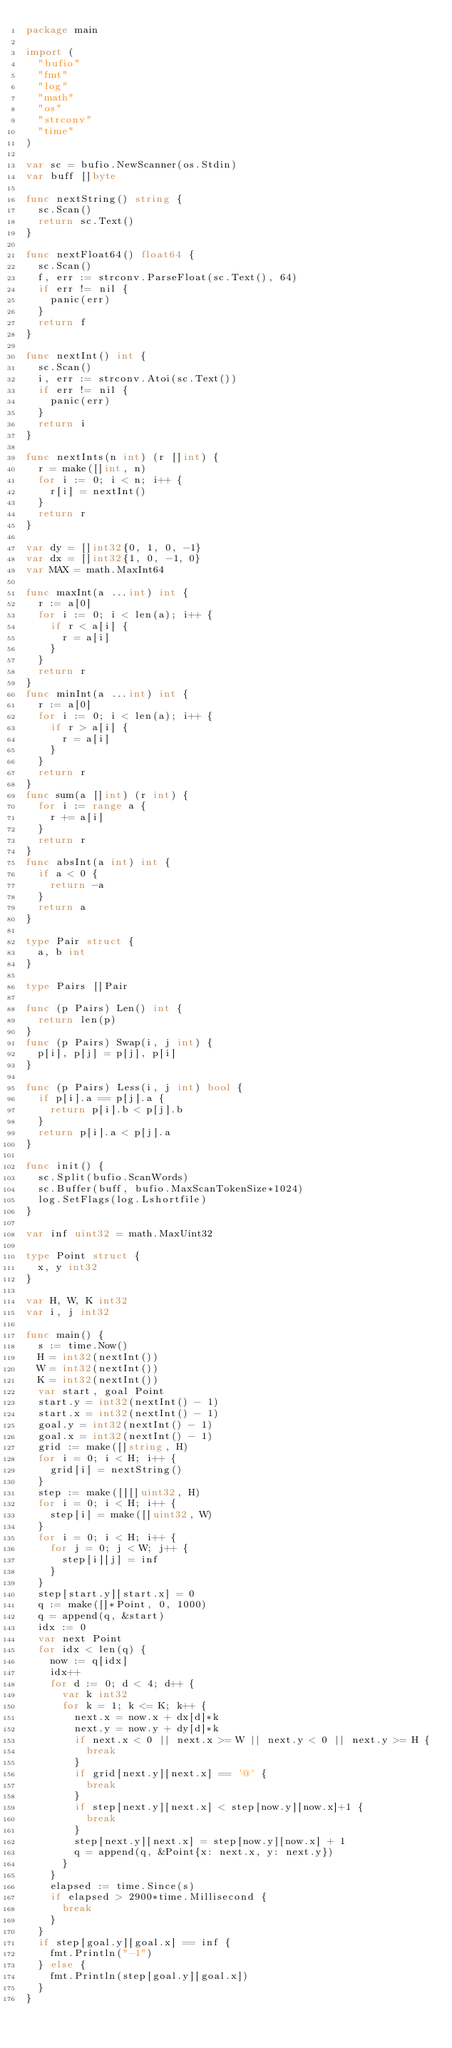<code> <loc_0><loc_0><loc_500><loc_500><_Go_>package main

import (
	"bufio"
	"fmt"
	"log"
	"math"
	"os"
	"strconv"
	"time"
)

var sc = bufio.NewScanner(os.Stdin)
var buff []byte

func nextString() string {
	sc.Scan()
	return sc.Text()
}

func nextFloat64() float64 {
	sc.Scan()
	f, err := strconv.ParseFloat(sc.Text(), 64)
	if err != nil {
		panic(err)
	}
	return f
}

func nextInt() int {
	sc.Scan()
	i, err := strconv.Atoi(sc.Text())
	if err != nil {
		panic(err)
	}
	return i
}

func nextInts(n int) (r []int) {
	r = make([]int, n)
	for i := 0; i < n; i++ {
		r[i] = nextInt()
	}
	return r
}

var dy = []int32{0, 1, 0, -1}
var dx = []int32{1, 0, -1, 0}
var MAX = math.MaxInt64

func maxInt(a ...int) int {
	r := a[0]
	for i := 0; i < len(a); i++ {
		if r < a[i] {
			r = a[i]
		}
	}
	return r
}
func minInt(a ...int) int {
	r := a[0]
	for i := 0; i < len(a); i++ {
		if r > a[i] {
			r = a[i]
		}
	}
	return r
}
func sum(a []int) (r int) {
	for i := range a {
		r += a[i]
	}
	return r
}
func absInt(a int) int {
	if a < 0 {
		return -a
	}
	return a
}

type Pair struct {
	a, b int
}

type Pairs []Pair

func (p Pairs) Len() int {
	return len(p)
}
func (p Pairs) Swap(i, j int) {
	p[i], p[j] = p[j], p[i]
}

func (p Pairs) Less(i, j int) bool {
	if p[i].a == p[j].a {
		return p[i].b < p[j].b
	}
	return p[i].a < p[j].a
}

func init() {
	sc.Split(bufio.ScanWords)
	sc.Buffer(buff, bufio.MaxScanTokenSize*1024)
	log.SetFlags(log.Lshortfile)
}

var inf uint32 = math.MaxUint32

type Point struct {
	x, y int32
}

var H, W, K int32
var i, j int32

func main() {
	s := time.Now()
	H = int32(nextInt())
	W = int32(nextInt())
	K = int32(nextInt())
	var start, goal Point
	start.y = int32(nextInt() - 1)
	start.x = int32(nextInt() - 1)
	goal.y = int32(nextInt() - 1)
	goal.x = int32(nextInt() - 1)
	grid := make([]string, H)
	for i = 0; i < H; i++ {
		grid[i] = nextString()
	}
	step := make([][]uint32, H)
	for i = 0; i < H; i++ {
		step[i] = make([]uint32, W)
	}
	for i = 0; i < H; i++ {
		for j = 0; j < W; j++ {
			step[i][j] = inf
		}
	}
	step[start.y][start.x] = 0
	q := make([]*Point, 0, 1000)
	q = append(q, &start)
	idx := 0
	var next Point
	for idx < len(q) {
		now := q[idx]
		idx++
		for d := 0; d < 4; d++ {
			var k int32
			for k = 1; k <= K; k++ {
				next.x = now.x + dx[d]*k
				next.y = now.y + dy[d]*k
				if next.x < 0 || next.x >= W || next.y < 0 || next.y >= H {
					break
				}
				if grid[next.y][next.x] == '@' {
					break
				}
				if step[next.y][next.x] < step[now.y][now.x]+1 {
					break
				}
				step[next.y][next.x] = step[now.y][now.x] + 1
				q = append(q, &Point{x: next.x, y: next.y})
			}
		}
		elapsed := time.Since(s)
		if elapsed > 2900*time.Millisecond {
			break
		}
	}
	if step[goal.y][goal.x] == inf {
		fmt.Println("-1")
	} else {
		fmt.Println(step[goal.y][goal.x])
	}
}
</code> 